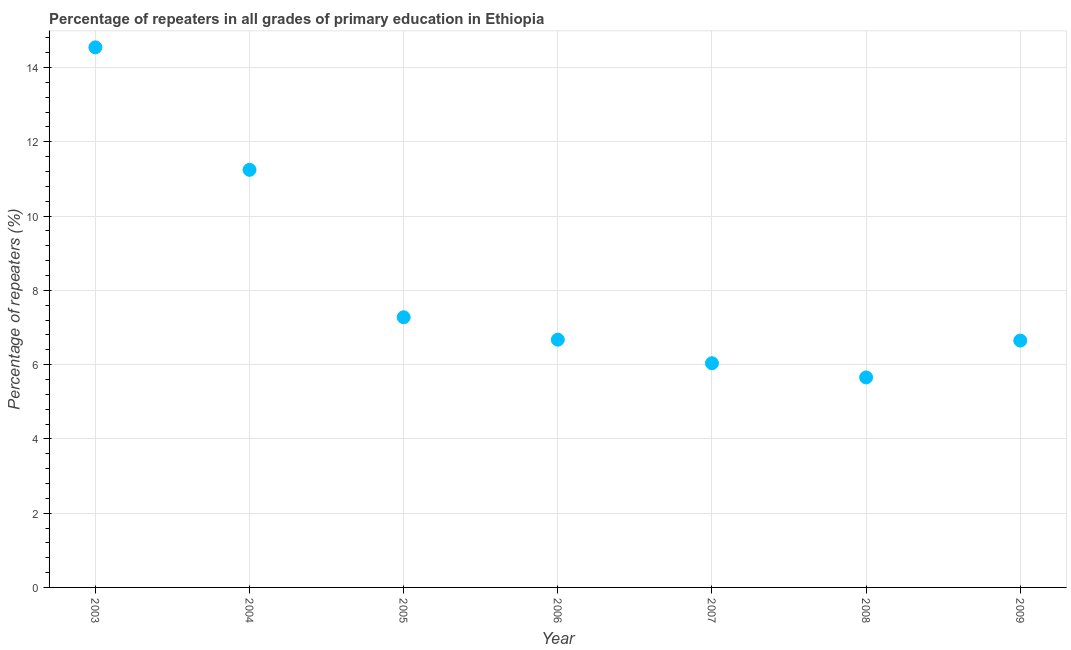What is the percentage of repeaters in primary education in 2008?
Provide a short and direct response. 5.66. Across all years, what is the maximum percentage of repeaters in primary education?
Offer a terse response. 14.54. Across all years, what is the minimum percentage of repeaters in primary education?
Make the answer very short. 5.66. In which year was the percentage of repeaters in primary education minimum?
Your answer should be very brief. 2008. What is the sum of the percentage of repeaters in primary education?
Give a very brief answer. 58.08. What is the difference between the percentage of repeaters in primary education in 2004 and 2005?
Your answer should be compact. 3.97. What is the average percentage of repeaters in primary education per year?
Make the answer very short. 8.3. What is the median percentage of repeaters in primary education?
Provide a short and direct response. 6.67. What is the ratio of the percentage of repeaters in primary education in 2005 to that in 2008?
Make the answer very short. 1.29. What is the difference between the highest and the second highest percentage of repeaters in primary education?
Your answer should be very brief. 3.3. What is the difference between the highest and the lowest percentage of repeaters in primary education?
Give a very brief answer. 8.89. Does the percentage of repeaters in primary education monotonically increase over the years?
Ensure brevity in your answer.  No. How many dotlines are there?
Make the answer very short. 1. What is the title of the graph?
Ensure brevity in your answer.  Percentage of repeaters in all grades of primary education in Ethiopia. What is the label or title of the X-axis?
Make the answer very short. Year. What is the label or title of the Y-axis?
Ensure brevity in your answer.  Percentage of repeaters (%). What is the Percentage of repeaters (%) in 2003?
Offer a very short reply. 14.54. What is the Percentage of repeaters (%) in 2004?
Your answer should be very brief. 11.25. What is the Percentage of repeaters (%) in 2005?
Your answer should be compact. 7.28. What is the Percentage of repeaters (%) in 2006?
Your answer should be very brief. 6.67. What is the Percentage of repeaters (%) in 2007?
Your response must be concise. 6.04. What is the Percentage of repeaters (%) in 2008?
Your answer should be compact. 5.66. What is the Percentage of repeaters (%) in 2009?
Offer a very short reply. 6.65. What is the difference between the Percentage of repeaters (%) in 2003 and 2004?
Your answer should be very brief. 3.3. What is the difference between the Percentage of repeaters (%) in 2003 and 2005?
Offer a very short reply. 7.27. What is the difference between the Percentage of repeaters (%) in 2003 and 2006?
Ensure brevity in your answer.  7.87. What is the difference between the Percentage of repeaters (%) in 2003 and 2007?
Your answer should be compact. 8.51. What is the difference between the Percentage of repeaters (%) in 2003 and 2008?
Provide a short and direct response. 8.89. What is the difference between the Percentage of repeaters (%) in 2003 and 2009?
Give a very brief answer. 7.9. What is the difference between the Percentage of repeaters (%) in 2004 and 2005?
Ensure brevity in your answer.  3.97. What is the difference between the Percentage of repeaters (%) in 2004 and 2006?
Offer a very short reply. 4.57. What is the difference between the Percentage of repeaters (%) in 2004 and 2007?
Provide a short and direct response. 5.21. What is the difference between the Percentage of repeaters (%) in 2004 and 2008?
Give a very brief answer. 5.59. What is the difference between the Percentage of repeaters (%) in 2004 and 2009?
Give a very brief answer. 4.6. What is the difference between the Percentage of repeaters (%) in 2005 and 2006?
Keep it short and to the point. 0.6. What is the difference between the Percentage of repeaters (%) in 2005 and 2007?
Keep it short and to the point. 1.24. What is the difference between the Percentage of repeaters (%) in 2005 and 2008?
Provide a succinct answer. 1.62. What is the difference between the Percentage of repeaters (%) in 2005 and 2009?
Your answer should be very brief. 0.63. What is the difference between the Percentage of repeaters (%) in 2006 and 2007?
Your answer should be compact. 0.63. What is the difference between the Percentage of repeaters (%) in 2006 and 2008?
Keep it short and to the point. 1.02. What is the difference between the Percentage of repeaters (%) in 2006 and 2009?
Offer a terse response. 0.02. What is the difference between the Percentage of repeaters (%) in 2007 and 2008?
Ensure brevity in your answer.  0.38. What is the difference between the Percentage of repeaters (%) in 2007 and 2009?
Keep it short and to the point. -0.61. What is the difference between the Percentage of repeaters (%) in 2008 and 2009?
Make the answer very short. -0.99. What is the ratio of the Percentage of repeaters (%) in 2003 to that in 2004?
Ensure brevity in your answer.  1.29. What is the ratio of the Percentage of repeaters (%) in 2003 to that in 2005?
Provide a short and direct response. 2. What is the ratio of the Percentage of repeaters (%) in 2003 to that in 2006?
Keep it short and to the point. 2.18. What is the ratio of the Percentage of repeaters (%) in 2003 to that in 2007?
Your answer should be compact. 2.41. What is the ratio of the Percentage of repeaters (%) in 2003 to that in 2008?
Your answer should be compact. 2.57. What is the ratio of the Percentage of repeaters (%) in 2003 to that in 2009?
Keep it short and to the point. 2.19. What is the ratio of the Percentage of repeaters (%) in 2004 to that in 2005?
Provide a short and direct response. 1.55. What is the ratio of the Percentage of repeaters (%) in 2004 to that in 2006?
Keep it short and to the point. 1.69. What is the ratio of the Percentage of repeaters (%) in 2004 to that in 2007?
Offer a terse response. 1.86. What is the ratio of the Percentage of repeaters (%) in 2004 to that in 2008?
Offer a terse response. 1.99. What is the ratio of the Percentage of repeaters (%) in 2004 to that in 2009?
Give a very brief answer. 1.69. What is the ratio of the Percentage of repeaters (%) in 2005 to that in 2006?
Make the answer very short. 1.09. What is the ratio of the Percentage of repeaters (%) in 2005 to that in 2007?
Your answer should be very brief. 1.21. What is the ratio of the Percentage of repeaters (%) in 2005 to that in 2008?
Your answer should be very brief. 1.29. What is the ratio of the Percentage of repeaters (%) in 2005 to that in 2009?
Provide a succinct answer. 1.09. What is the ratio of the Percentage of repeaters (%) in 2006 to that in 2007?
Offer a very short reply. 1.1. What is the ratio of the Percentage of repeaters (%) in 2006 to that in 2008?
Your answer should be very brief. 1.18. What is the ratio of the Percentage of repeaters (%) in 2006 to that in 2009?
Offer a terse response. 1. What is the ratio of the Percentage of repeaters (%) in 2007 to that in 2008?
Your answer should be compact. 1.07. What is the ratio of the Percentage of repeaters (%) in 2007 to that in 2009?
Your answer should be very brief. 0.91. What is the ratio of the Percentage of repeaters (%) in 2008 to that in 2009?
Give a very brief answer. 0.85. 